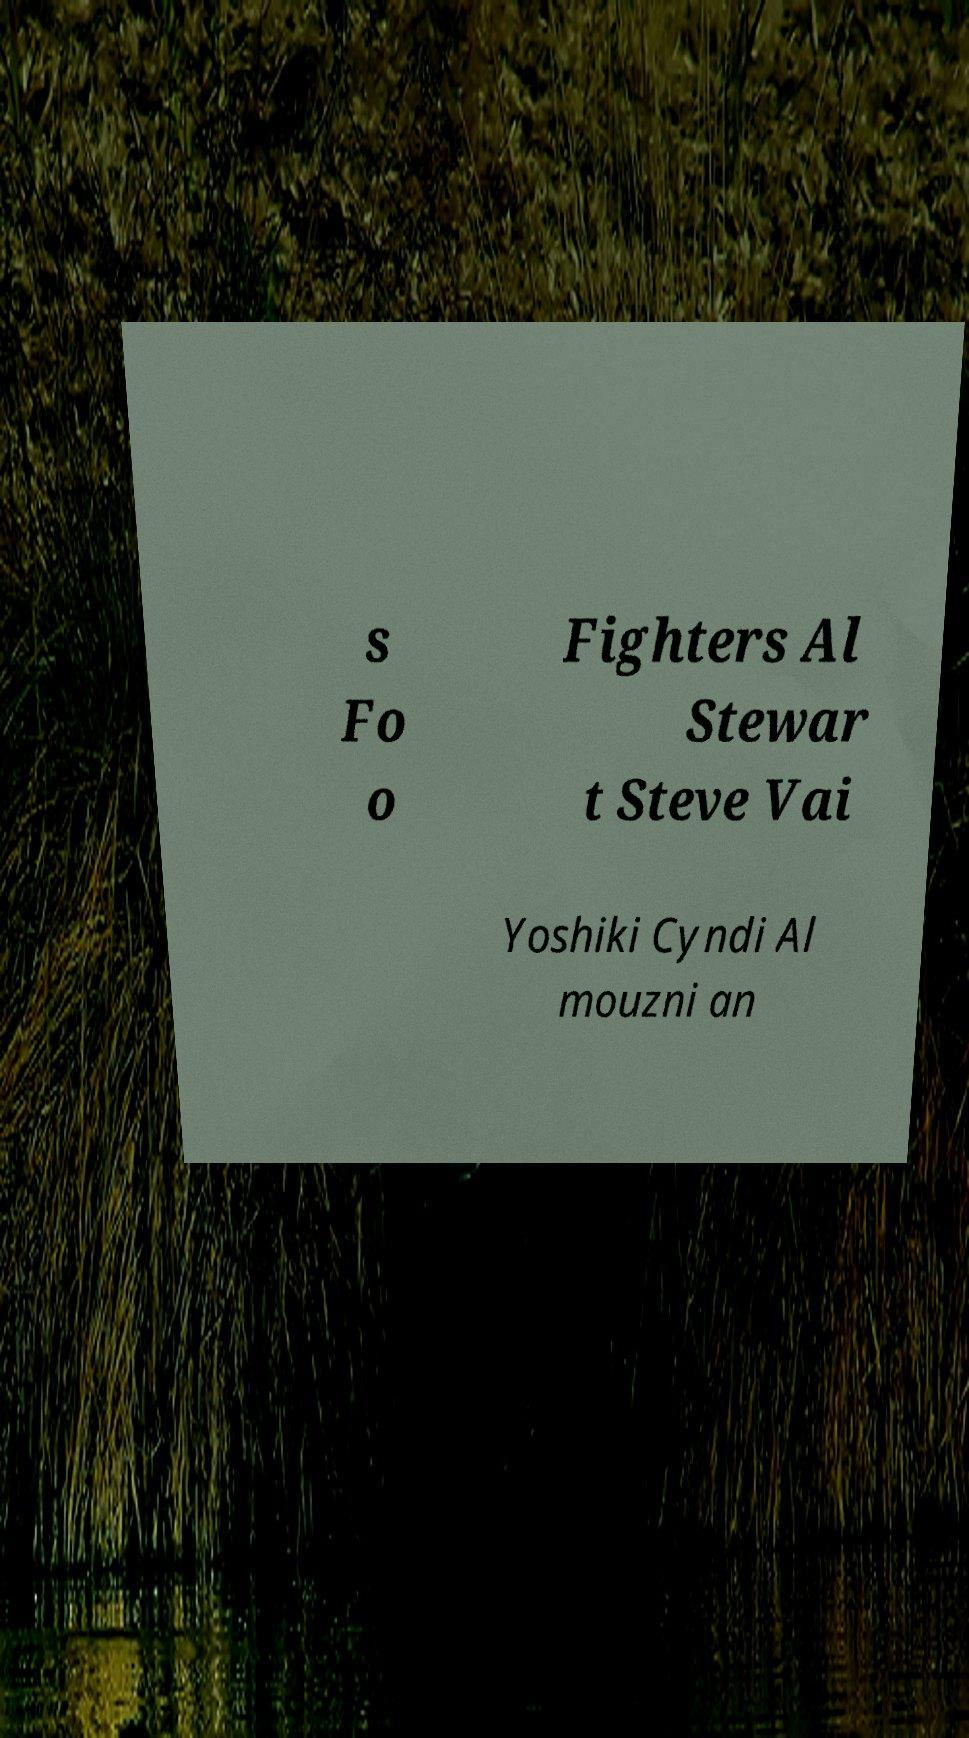Could you extract and type out the text from this image? s Fo o Fighters Al Stewar t Steve Vai Yoshiki Cyndi Al mouzni an 